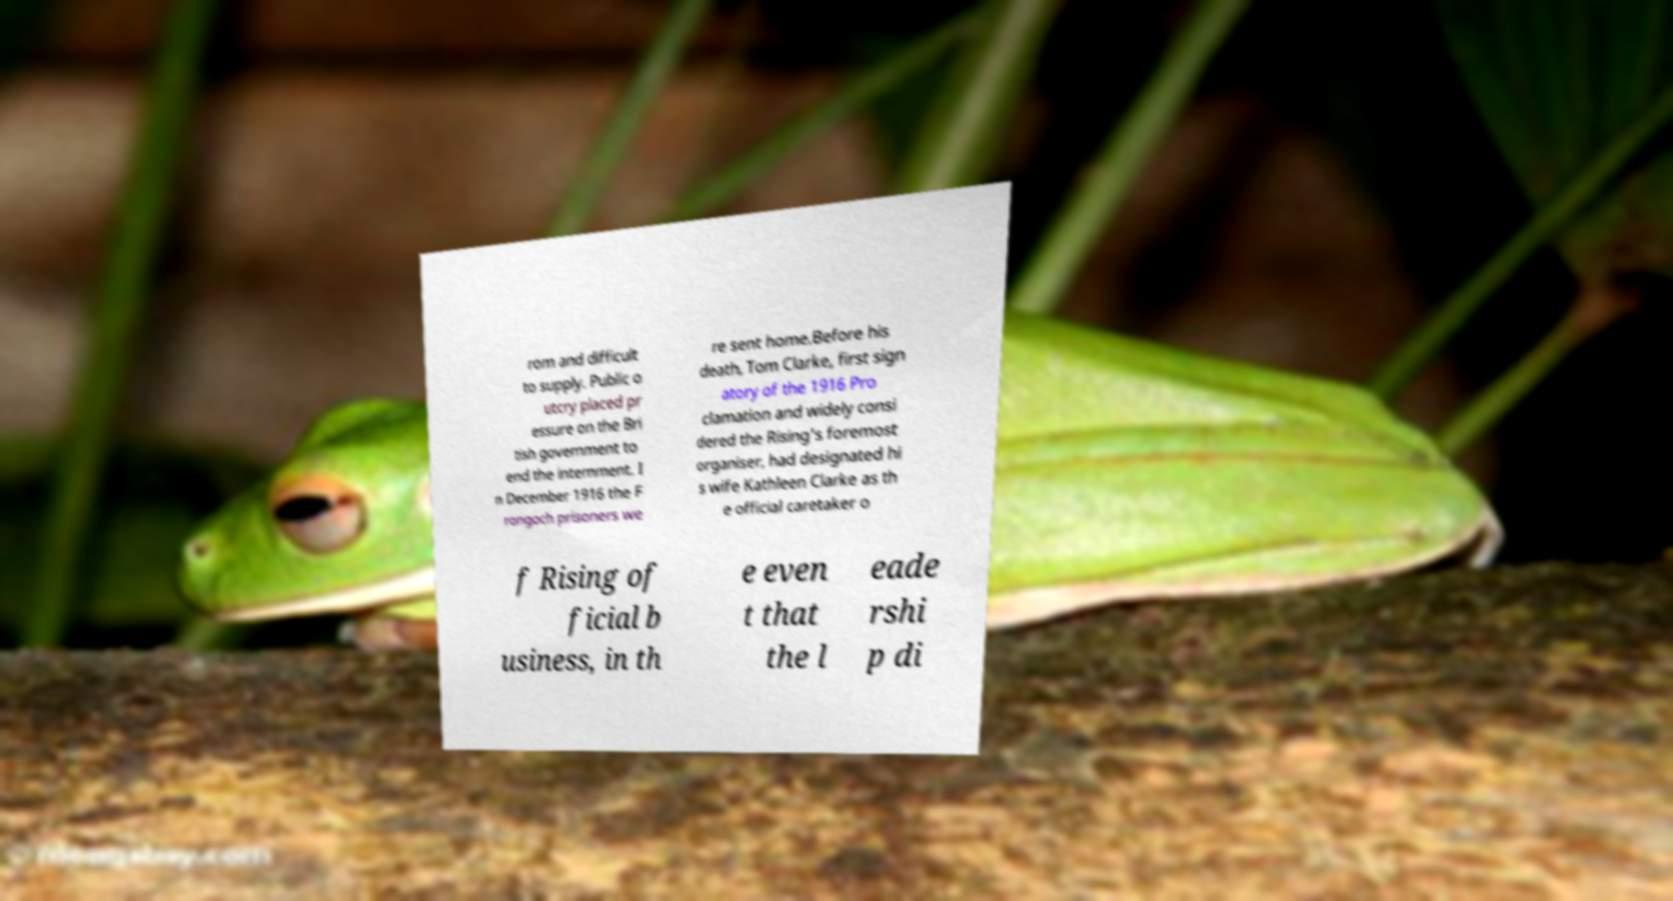Can you accurately transcribe the text from the provided image for me? rom and difficult to supply. Public o utcry placed pr essure on the Bri tish government to end the internment. I n December 1916 the F rongoch prisoners we re sent home.Before his death, Tom Clarke, first sign atory of the 1916 Pro clamation and widely consi dered the Rising's foremost organiser, had designated hi s wife Kathleen Clarke as th e official caretaker o f Rising of ficial b usiness, in th e even t that the l eade rshi p di 